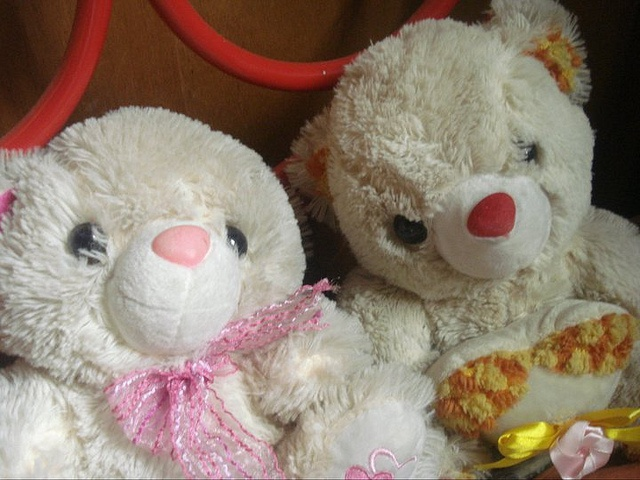Describe the objects in this image and their specific colors. I can see teddy bear in black, darkgray, lightgray, and pink tones and teddy bear in black, darkgray, gray, and olive tones in this image. 